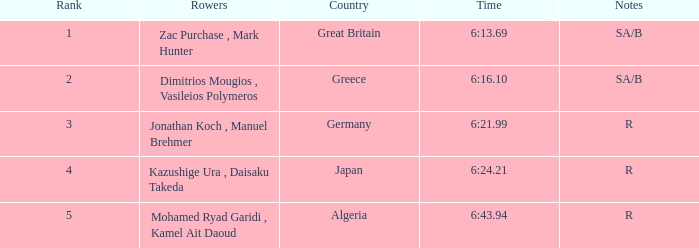What country is ranked #2? Greece. 